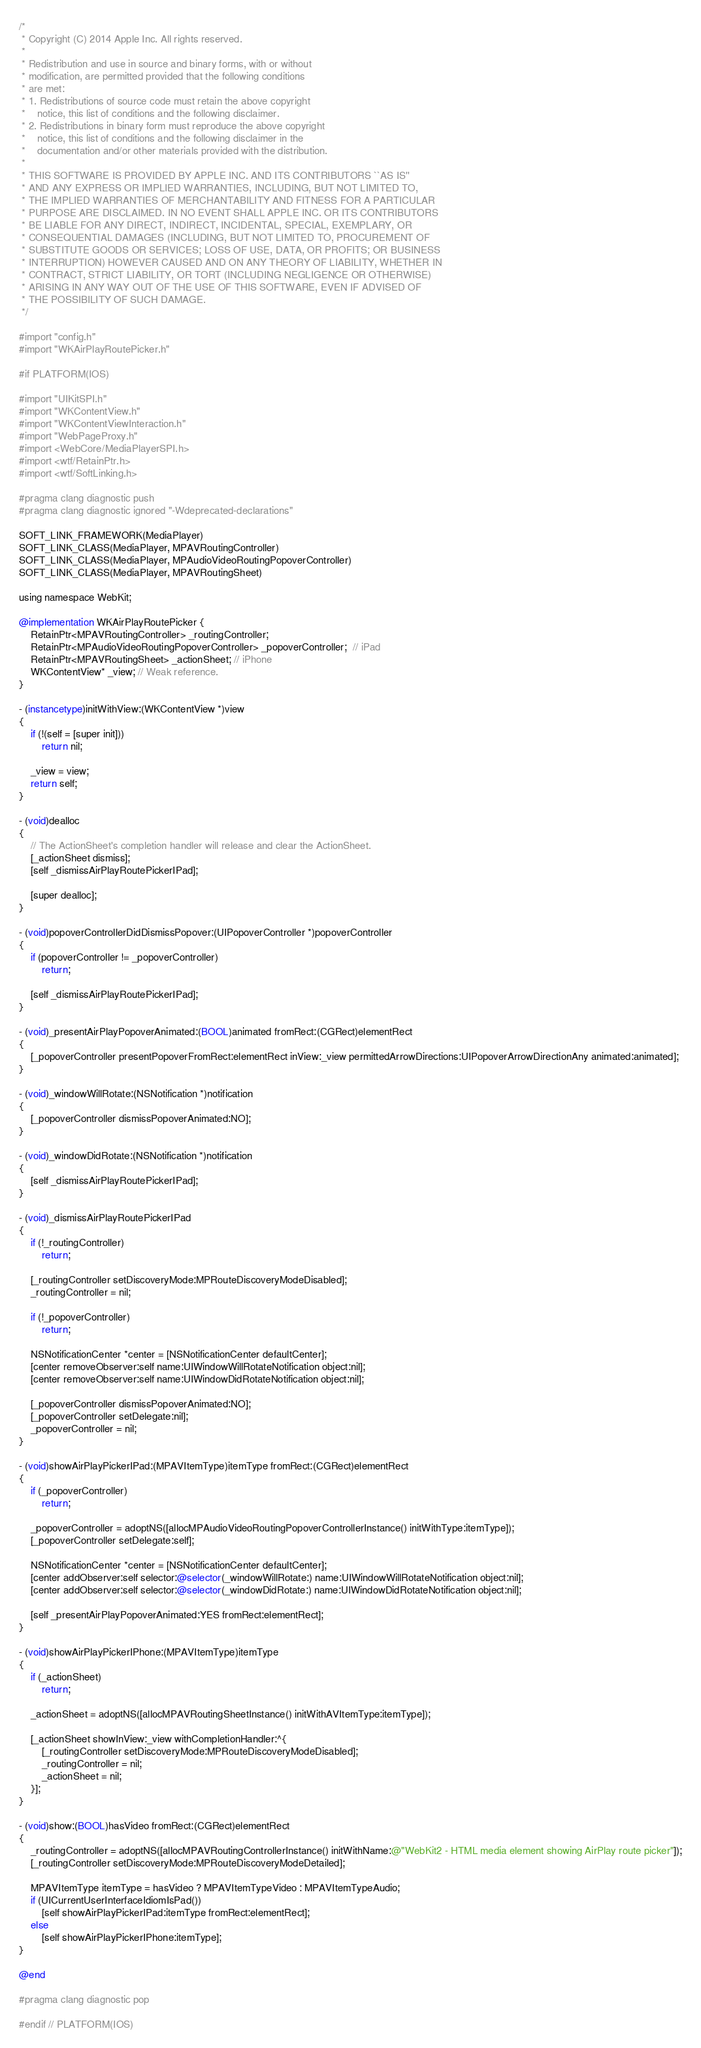<code> <loc_0><loc_0><loc_500><loc_500><_ObjectiveC_>/*
 * Copyright (C) 2014 Apple Inc. All rights reserved.
 *
 * Redistribution and use in source and binary forms, with or without
 * modification, are permitted provided that the following conditions
 * are met:
 * 1. Redistributions of source code must retain the above copyright
 *    notice, this list of conditions and the following disclaimer.
 * 2. Redistributions in binary form must reproduce the above copyright
 *    notice, this list of conditions and the following disclaimer in the
 *    documentation and/or other materials provided with the distribution.
 *
 * THIS SOFTWARE IS PROVIDED BY APPLE INC. AND ITS CONTRIBUTORS ``AS IS''
 * AND ANY EXPRESS OR IMPLIED WARRANTIES, INCLUDING, BUT NOT LIMITED TO,
 * THE IMPLIED WARRANTIES OF MERCHANTABILITY AND FITNESS FOR A PARTICULAR
 * PURPOSE ARE DISCLAIMED. IN NO EVENT SHALL APPLE INC. OR ITS CONTRIBUTORS
 * BE LIABLE FOR ANY DIRECT, INDIRECT, INCIDENTAL, SPECIAL, EXEMPLARY, OR
 * CONSEQUENTIAL DAMAGES (INCLUDING, BUT NOT LIMITED TO, PROCUREMENT OF
 * SUBSTITUTE GOODS OR SERVICES; LOSS OF USE, DATA, OR PROFITS; OR BUSINESS
 * INTERRUPTION) HOWEVER CAUSED AND ON ANY THEORY OF LIABILITY, WHETHER IN
 * CONTRACT, STRICT LIABILITY, OR TORT (INCLUDING NEGLIGENCE OR OTHERWISE)
 * ARISING IN ANY WAY OUT OF THE USE OF THIS SOFTWARE, EVEN IF ADVISED OF
 * THE POSSIBILITY OF SUCH DAMAGE.
 */

#import "config.h"
#import "WKAirPlayRoutePicker.h"

#if PLATFORM(IOS)

#import "UIKitSPI.h"
#import "WKContentView.h"
#import "WKContentViewInteraction.h"
#import "WebPageProxy.h"
#import <WebCore/MediaPlayerSPI.h>
#import <wtf/RetainPtr.h>
#import <wtf/SoftLinking.h>

#pragma clang diagnostic push
#pragma clang diagnostic ignored "-Wdeprecated-declarations"

SOFT_LINK_FRAMEWORK(MediaPlayer)
SOFT_LINK_CLASS(MediaPlayer, MPAVRoutingController)
SOFT_LINK_CLASS(MediaPlayer, MPAudioVideoRoutingPopoverController)
SOFT_LINK_CLASS(MediaPlayer, MPAVRoutingSheet)

using namespace WebKit;

@implementation WKAirPlayRoutePicker {
    RetainPtr<MPAVRoutingController> _routingController;
    RetainPtr<MPAudioVideoRoutingPopoverController> _popoverController;  // iPad
    RetainPtr<MPAVRoutingSheet> _actionSheet; // iPhone
    WKContentView* _view; // Weak reference.
}

- (instancetype)initWithView:(WKContentView *)view
{
    if (!(self = [super init]))
        return nil;

    _view = view;
    return self;
}

- (void)dealloc
{
    // The ActionSheet's completion handler will release and clear the ActionSheet.
    [_actionSheet dismiss];
    [self _dismissAirPlayRoutePickerIPad];

    [super dealloc];
}

- (void)popoverControllerDidDismissPopover:(UIPopoverController *)popoverController
{
    if (popoverController != _popoverController)
        return;

    [self _dismissAirPlayRoutePickerIPad];
}

- (void)_presentAirPlayPopoverAnimated:(BOOL)animated fromRect:(CGRect)elementRect
{
    [_popoverController presentPopoverFromRect:elementRect inView:_view permittedArrowDirections:UIPopoverArrowDirectionAny animated:animated];
}

- (void)_windowWillRotate:(NSNotification *)notification
{
    [_popoverController dismissPopoverAnimated:NO];
}

- (void)_windowDidRotate:(NSNotification *)notification
{
    [self _dismissAirPlayRoutePickerIPad];
}

- (void)_dismissAirPlayRoutePickerIPad
{
    if (!_routingController)
        return;

    [_routingController setDiscoveryMode:MPRouteDiscoveryModeDisabled];
    _routingController = nil;

    if (!_popoverController)
        return;

    NSNotificationCenter *center = [NSNotificationCenter defaultCenter];
    [center removeObserver:self name:UIWindowWillRotateNotification object:nil];
    [center removeObserver:self name:UIWindowDidRotateNotification object:nil];

    [_popoverController dismissPopoverAnimated:NO];
    [_popoverController setDelegate:nil];
    _popoverController = nil;
}

- (void)showAirPlayPickerIPad:(MPAVItemType)itemType fromRect:(CGRect)elementRect
{
    if (_popoverController)
        return;

    _popoverController = adoptNS([allocMPAudioVideoRoutingPopoverControllerInstance() initWithType:itemType]);
    [_popoverController setDelegate:self];

    NSNotificationCenter *center = [NSNotificationCenter defaultCenter];
    [center addObserver:self selector:@selector(_windowWillRotate:) name:UIWindowWillRotateNotification object:nil];
    [center addObserver:self selector:@selector(_windowDidRotate:) name:UIWindowDidRotateNotification object:nil];

    [self _presentAirPlayPopoverAnimated:YES fromRect:elementRect];
}

- (void)showAirPlayPickerIPhone:(MPAVItemType)itemType
{
    if (_actionSheet)
        return;

    _actionSheet = adoptNS([allocMPAVRoutingSheetInstance() initWithAVItemType:itemType]);

    [_actionSheet showInView:_view withCompletionHandler:^{
        [_routingController setDiscoveryMode:MPRouteDiscoveryModeDisabled];
        _routingController = nil;
        _actionSheet = nil;
    }];
}

- (void)show:(BOOL)hasVideo fromRect:(CGRect)elementRect
{
    _routingController = adoptNS([allocMPAVRoutingControllerInstance() initWithName:@"WebKit2 - HTML media element showing AirPlay route picker"]);
    [_routingController setDiscoveryMode:MPRouteDiscoveryModeDetailed];

    MPAVItemType itemType = hasVideo ? MPAVItemTypeVideo : MPAVItemTypeAudio;
    if (UICurrentUserInterfaceIdiomIsPad())
        [self showAirPlayPickerIPad:itemType fromRect:elementRect];
    else
        [self showAirPlayPickerIPhone:itemType];
}

@end

#pragma clang diagnostic pop

#endif // PLATFORM(IOS)
</code> 